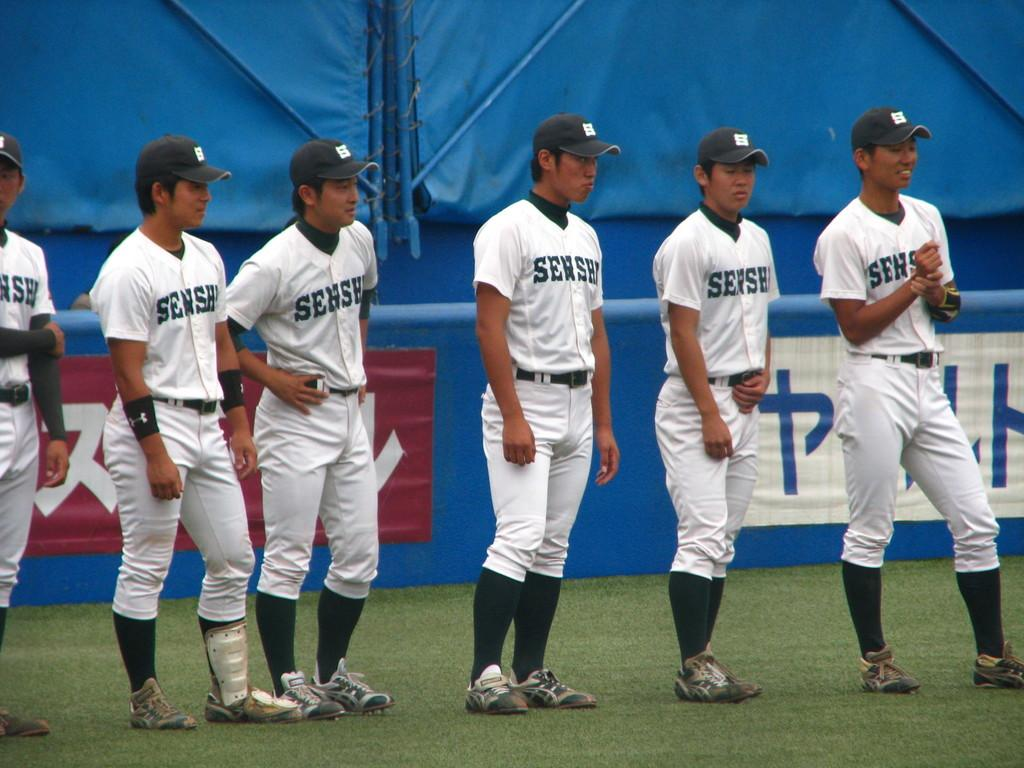<image>
Relay a brief, clear account of the picture shown. Baseball players with the word "Sehshi" on their chest. 